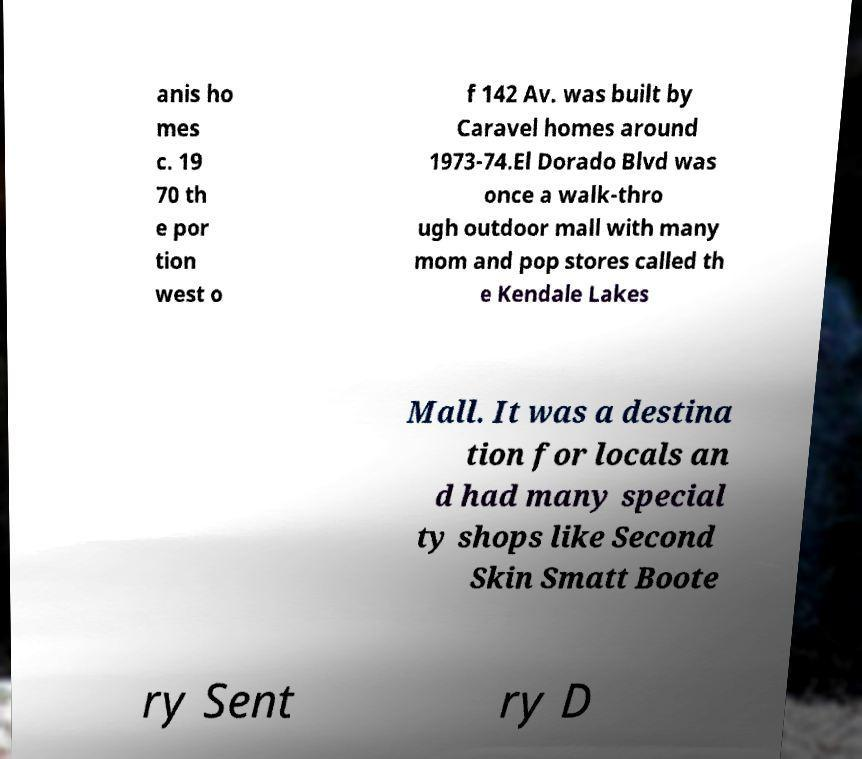Could you assist in decoding the text presented in this image and type it out clearly? anis ho mes c. 19 70 th e por tion west o f 142 Av. was built by Caravel homes around 1973-74.El Dorado Blvd was once a walk-thro ugh outdoor mall with many mom and pop stores called th e Kendale Lakes Mall. It was a destina tion for locals an d had many special ty shops like Second Skin Smatt Boote ry Sent ry D 